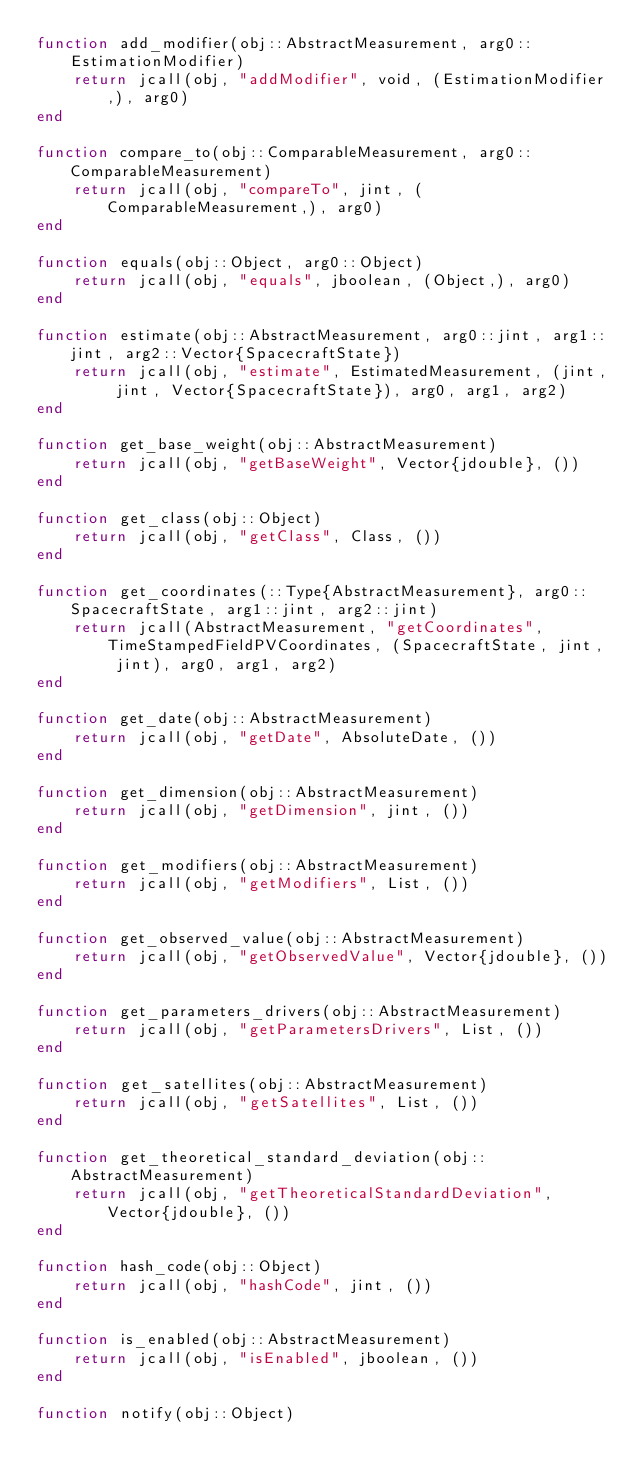<code> <loc_0><loc_0><loc_500><loc_500><_Julia_>function add_modifier(obj::AbstractMeasurement, arg0::EstimationModifier)
    return jcall(obj, "addModifier", void, (EstimationModifier,), arg0)
end

function compare_to(obj::ComparableMeasurement, arg0::ComparableMeasurement)
    return jcall(obj, "compareTo", jint, (ComparableMeasurement,), arg0)
end

function equals(obj::Object, arg0::Object)
    return jcall(obj, "equals", jboolean, (Object,), arg0)
end

function estimate(obj::AbstractMeasurement, arg0::jint, arg1::jint, arg2::Vector{SpacecraftState})
    return jcall(obj, "estimate", EstimatedMeasurement, (jint, jint, Vector{SpacecraftState}), arg0, arg1, arg2)
end

function get_base_weight(obj::AbstractMeasurement)
    return jcall(obj, "getBaseWeight", Vector{jdouble}, ())
end

function get_class(obj::Object)
    return jcall(obj, "getClass", Class, ())
end

function get_coordinates(::Type{AbstractMeasurement}, arg0::SpacecraftState, arg1::jint, arg2::jint)
    return jcall(AbstractMeasurement, "getCoordinates", TimeStampedFieldPVCoordinates, (SpacecraftState, jint, jint), arg0, arg1, arg2)
end

function get_date(obj::AbstractMeasurement)
    return jcall(obj, "getDate", AbsoluteDate, ())
end

function get_dimension(obj::AbstractMeasurement)
    return jcall(obj, "getDimension", jint, ())
end

function get_modifiers(obj::AbstractMeasurement)
    return jcall(obj, "getModifiers", List, ())
end

function get_observed_value(obj::AbstractMeasurement)
    return jcall(obj, "getObservedValue", Vector{jdouble}, ())
end

function get_parameters_drivers(obj::AbstractMeasurement)
    return jcall(obj, "getParametersDrivers", List, ())
end

function get_satellites(obj::AbstractMeasurement)
    return jcall(obj, "getSatellites", List, ())
end

function get_theoretical_standard_deviation(obj::AbstractMeasurement)
    return jcall(obj, "getTheoreticalStandardDeviation", Vector{jdouble}, ())
end

function hash_code(obj::Object)
    return jcall(obj, "hashCode", jint, ())
end

function is_enabled(obj::AbstractMeasurement)
    return jcall(obj, "isEnabled", jboolean, ())
end

function notify(obj::Object)</code> 